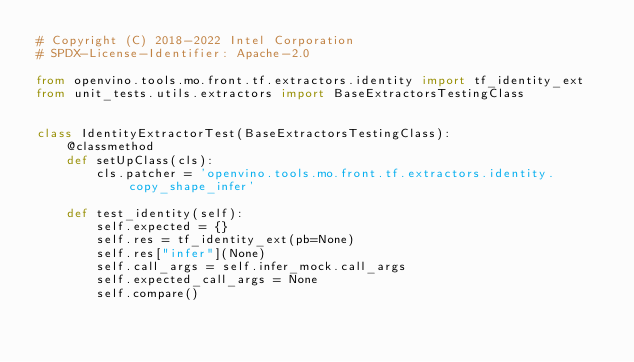Convert code to text. <code><loc_0><loc_0><loc_500><loc_500><_Python_># Copyright (C) 2018-2022 Intel Corporation
# SPDX-License-Identifier: Apache-2.0

from openvino.tools.mo.front.tf.extractors.identity import tf_identity_ext
from unit_tests.utils.extractors import BaseExtractorsTestingClass


class IdentityExtractorTest(BaseExtractorsTestingClass):
    @classmethod
    def setUpClass(cls):
        cls.patcher = 'openvino.tools.mo.front.tf.extractors.identity.copy_shape_infer'

    def test_identity(self):
        self.expected = {}
        self.res = tf_identity_ext(pb=None)
        self.res["infer"](None)
        self.call_args = self.infer_mock.call_args
        self.expected_call_args = None
        self.compare()
</code> 